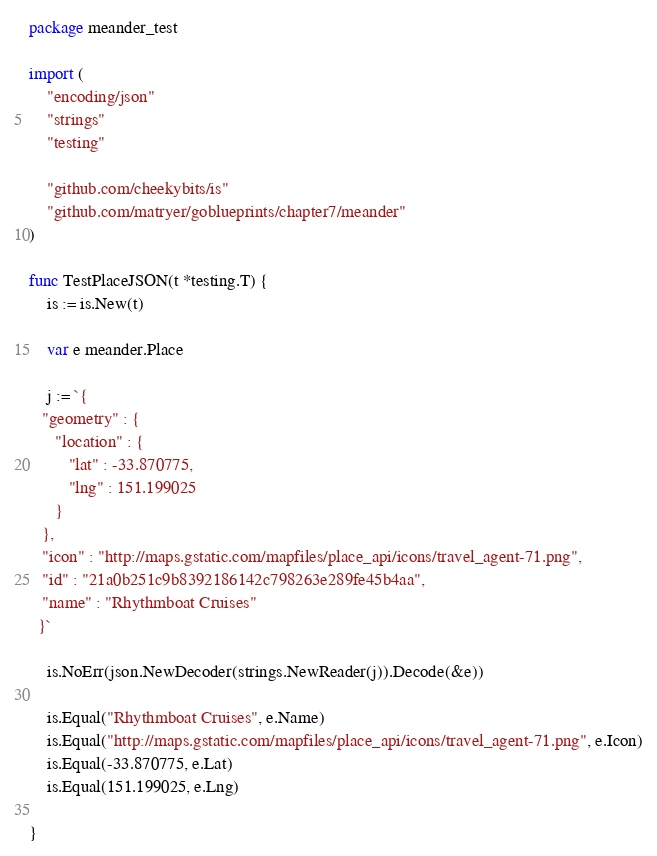<code> <loc_0><loc_0><loc_500><loc_500><_Go_>package meander_test

import (
	"encoding/json"
	"strings"
	"testing"

	"github.com/cheekybits/is"
	"github.com/matryer/goblueprints/chapter7/meander"
)

func TestPlaceJSON(t *testing.T) {
	is := is.New(t)

	var e meander.Place

	j := `{
   "geometry" : {
      "location" : {
         "lat" : -33.870775,
         "lng" : 151.199025
      }
   },
   "icon" : "http://maps.gstatic.com/mapfiles/place_api/icons/travel_agent-71.png",
   "id" : "21a0b251c9b8392186142c798263e289fe45b4aa",
   "name" : "Rhythmboat Cruises"
  }`

	is.NoErr(json.NewDecoder(strings.NewReader(j)).Decode(&e))

	is.Equal("Rhythmboat Cruises", e.Name)
	is.Equal("http://maps.gstatic.com/mapfiles/place_api/icons/travel_agent-71.png", e.Icon)
	is.Equal(-33.870775, e.Lat)
	is.Equal(151.199025, e.Lng)

}
</code> 